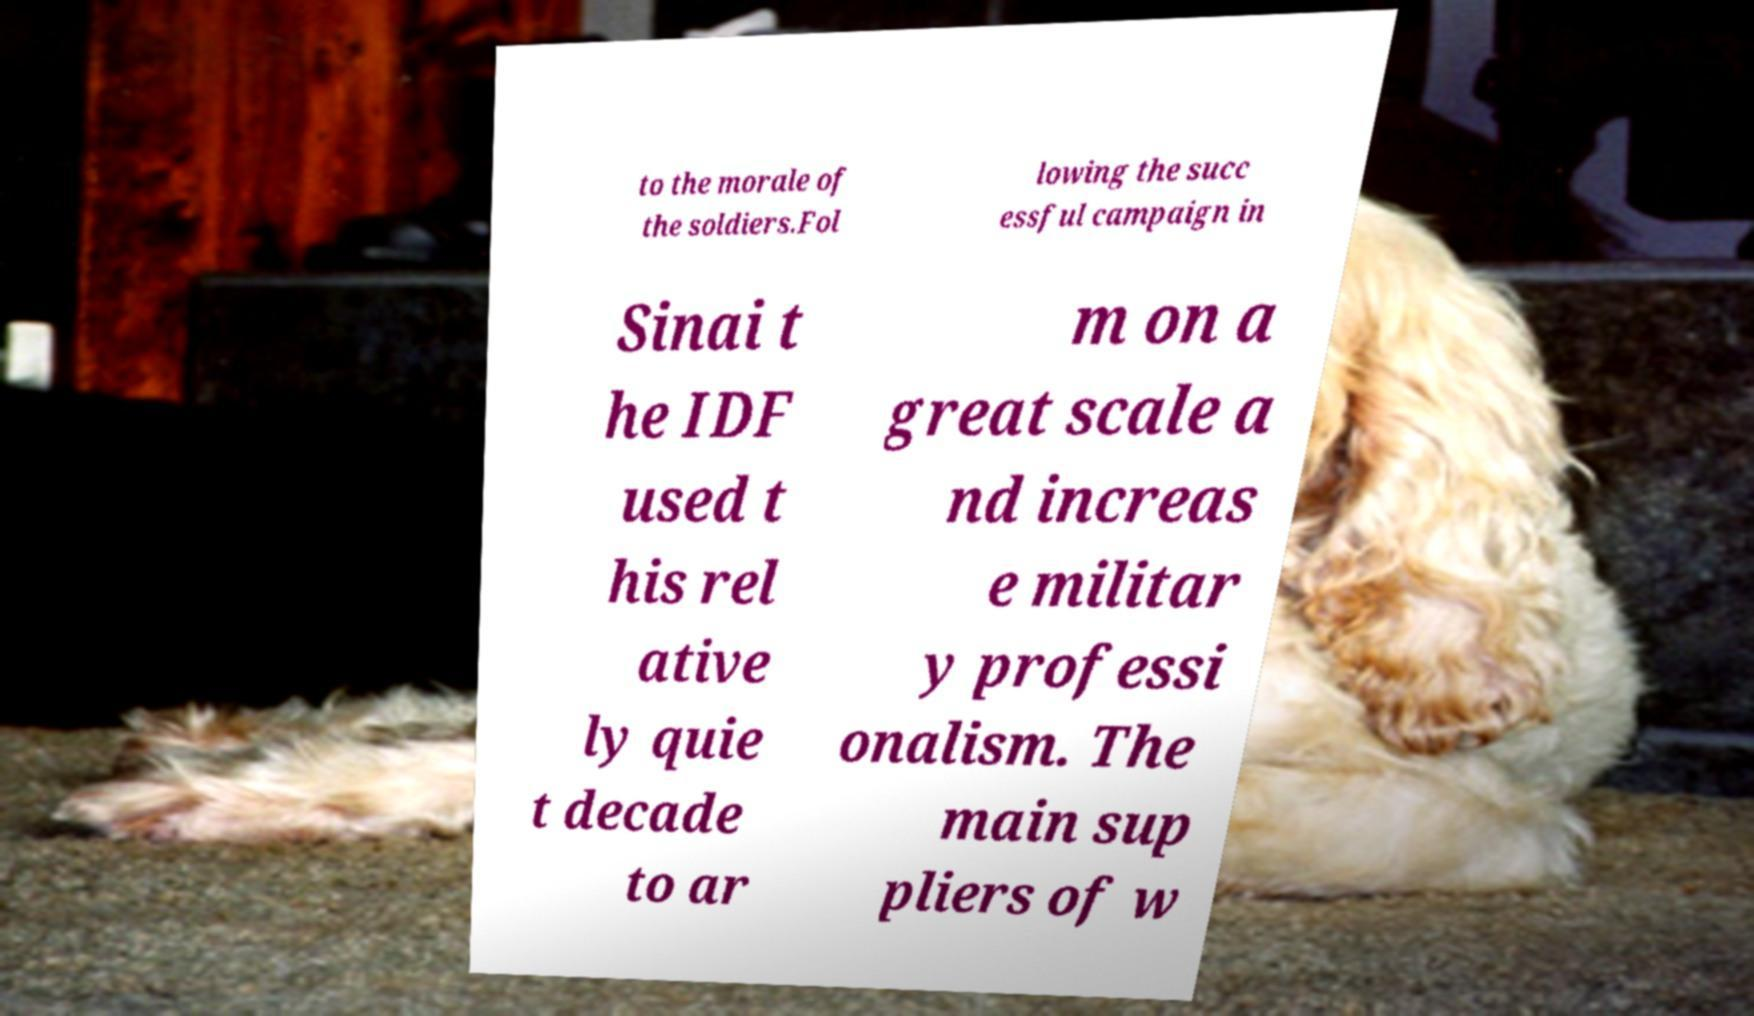Could you assist in decoding the text presented in this image and type it out clearly? to the morale of the soldiers.Fol lowing the succ essful campaign in Sinai t he IDF used t his rel ative ly quie t decade to ar m on a great scale a nd increas e militar y professi onalism. The main sup pliers of w 